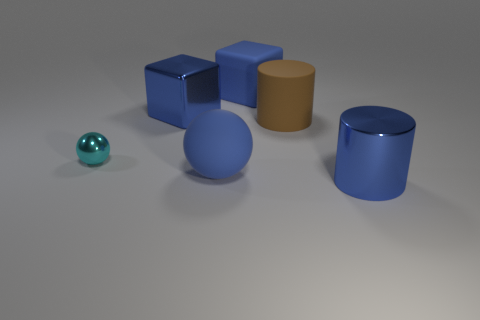How many things are big blue metallic cubes or purple spheres?
Provide a succinct answer. 1. What color is the other block that is the same size as the rubber block?
Your response must be concise. Blue. There is a big blue object that is behind the blue metal cube; what number of large metallic cylinders are right of it?
Ensure brevity in your answer.  1. How many objects are both behind the small cyan metal thing and left of the large rubber sphere?
Your answer should be very brief. 1. How many things are cylinders that are to the left of the blue cylinder or blue matte things that are behind the cyan thing?
Ensure brevity in your answer.  2. What number of other objects are the same size as the brown object?
Provide a succinct answer. 4. What is the shape of the blue rubber thing that is in front of the blue block on the right side of the blue ball?
Ensure brevity in your answer.  Sphere. Is the color of the big shiny object to the left of the large brown cylinder the same as the large cylinder on the right side of the brown thing?
Make the answer very short. Yes. Is there any other thing of the same color as the small sphere?
Your answer should be compact. No. What color is the big ball?
Make the answer very short. Blue. 